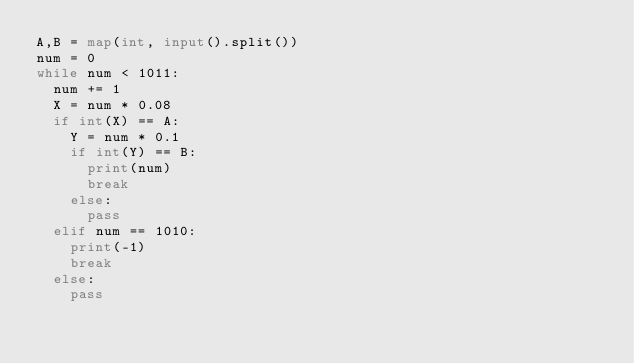Convert code to text. <code><loc_0><loc_0><loc_500><loc_500><_Python_>A,B = map(int, input().split())
num = 0
while num < 1011:
  num += 1
  X = num * 0.08
  if int(X) == A:
    Y = num * 0.1
    if int(Y) == B:
      print(num)
      break
    else:
      pass
  elif num == 1010:
    print(-1)
    break
  else:
    pass
</code> 